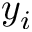<formula> <loc_0><loc_0><loc_500><loc_500>y _ { i }</formula> 